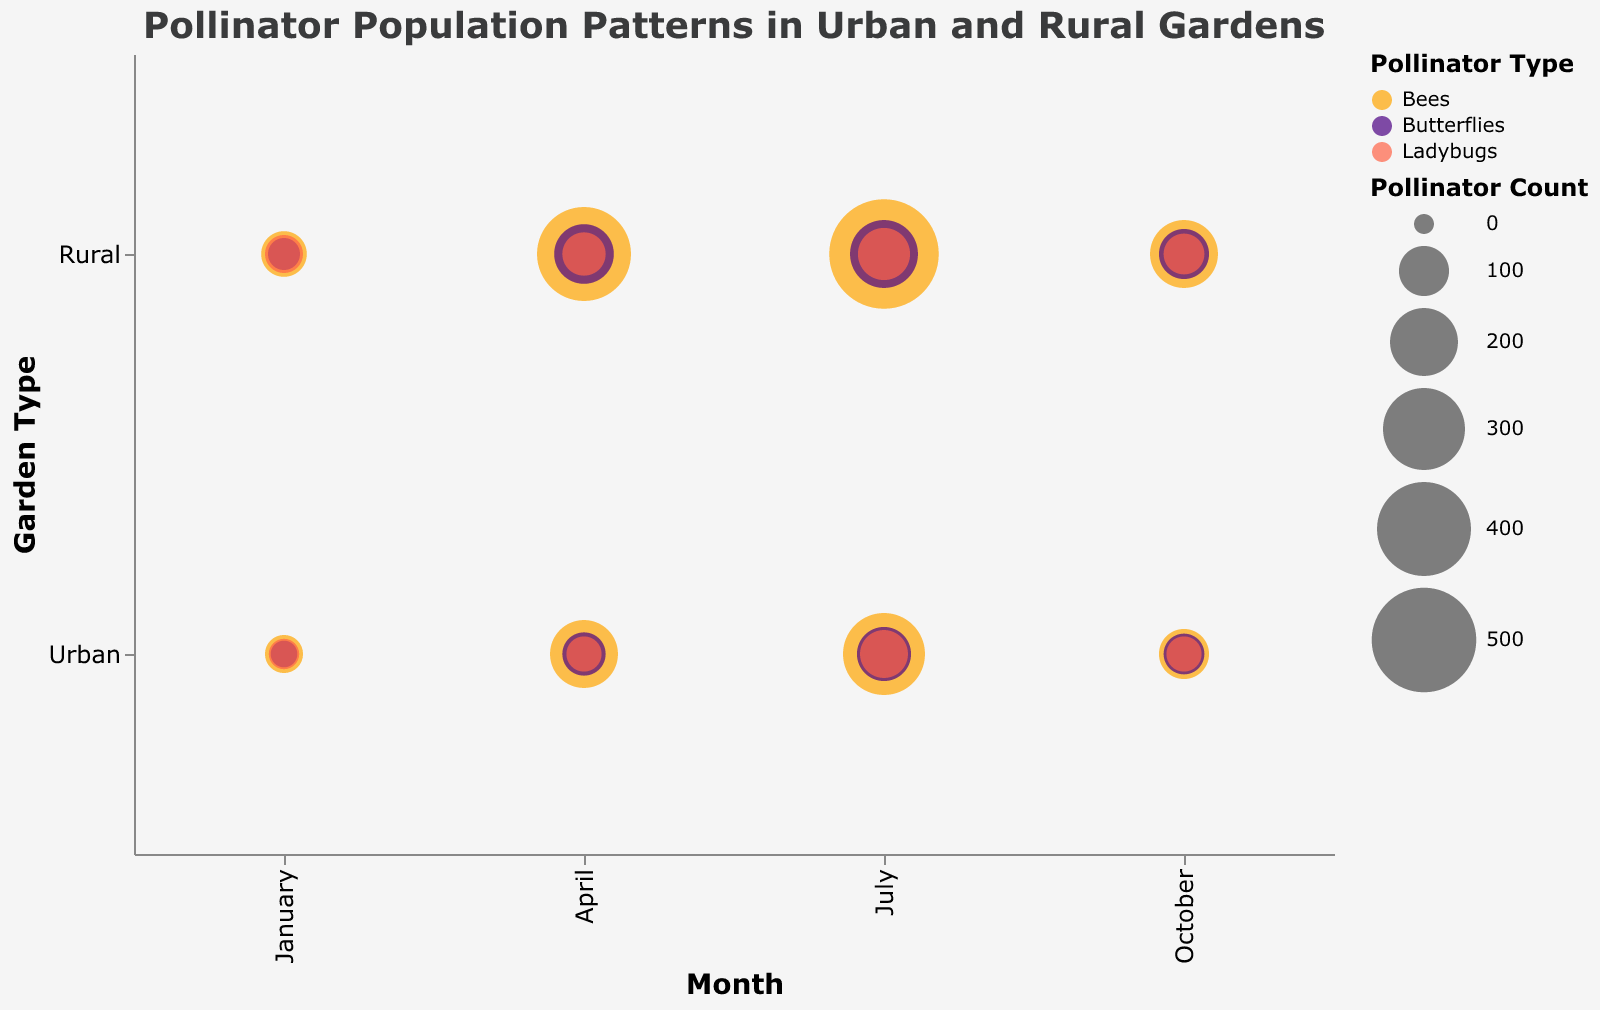How many data points represent pollinators in urban gardens during January? Look at the "Urban" row along the horizontal "Month" axis, specifically at "January". Count the number of data points (bubbles) present in that section.
Answer: 3 Which garden type has a higher count of bees in April? Compare the size of the bubbles representing bees in the "Urban" and "Rural" rows for the month of "April". The larger bubble indicates the higher count.
Answer: Rural What is the total population of butterflies in rural gardens in July? Find the bubble representing butterflies in the "Rural" row for the month of "July". The tooltip or bubble size reflects the population count.
Answer: 200 Between urban and rural gardens, which one has a larger average size (mm) of ladybugs in January? Look at the tooltip for the bubbles representing ladybugs in the "Urban" and "Rural" rows for January. The average size (mm) value is shown.
Answer: Rural Which month shows the highest increase in the pollinator count of bees between urban and rural gardens? Compare the size differences of bee bubbles between "Urban" and "Rural" rows across all months. April shows a significant difference due to larger bubble size in rural gardens.
Answer: April What is the average pollinator count of ladybugs across all months in rural gardens? Sum the ladybug pollinator counts in the "Rural" row for all months (50+70+110+60). Divide by the number of months (4).
Answer: 72.5 How does the pollinator population for butterflies in urban gardens change from January to July? Observe the size of the butterfly bubbles in the "Urban" row from January to July. The size increases, indicating an increase in population.
Answer: Increases Is the average size of bees larger in rural gardens or urban gardens? Compare the average size (mm) of bee bubbles in the tooltips from both "Urban" and "Rural" rows. Rural gardens have larger bee sizes on average.
Answer: Rural Which pollinator type has the smallest count in urban gardens in January? Check the tooltip for pollinator count values of all types in the "Urban" row for January. The smallest value is for butterflies.
Answer: Butterflies Are pollinator counts generally higher in urban or rural gardens in July? Compare the sizes of all pollinator type bubbles in both "Urban" and "Rural" rows for July. Rural gardens generally have larger bubbles indicating higher counts.
Answer: Rural 